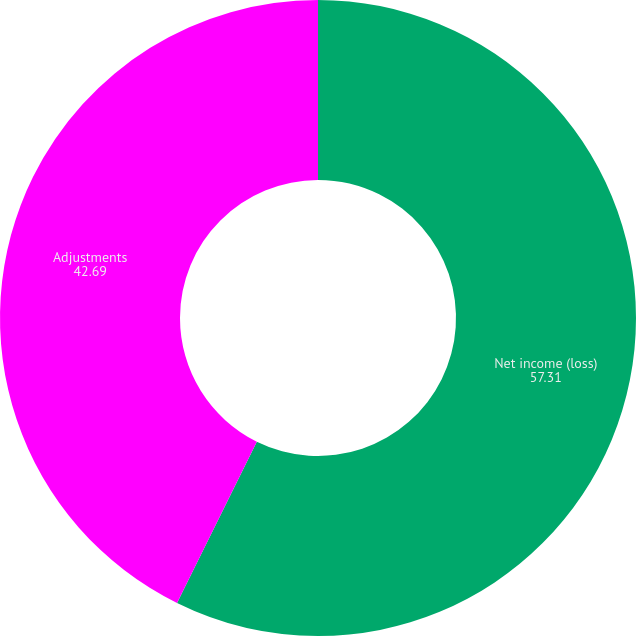<chart> <loc_0><loc_0><loc_500><loc_500><pie_chart><fcel>Net income (loss)<fcel>Adjustments<nl><fcel>57.31%<fcel>42.69%<nl></chart> 